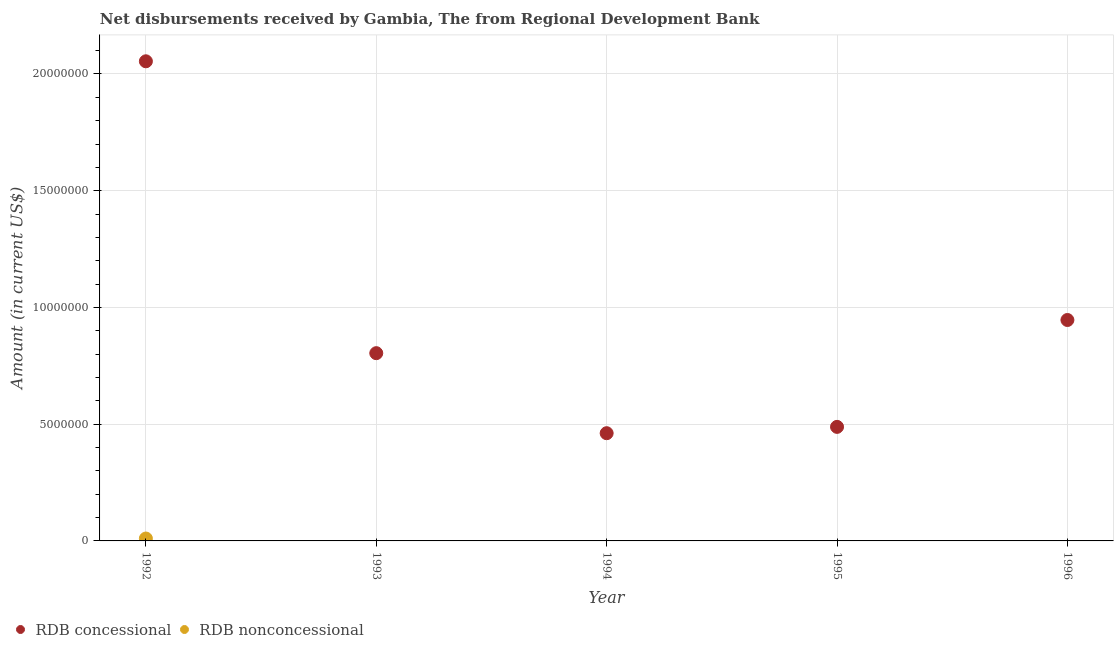How many different coloured dotlines are there?
Offer a very short reply. 2. Is the number of dotlines equal to the number of legend labels?
Your answer should be compact. No. Across all years, what is the maximum net concessional disbursements from rdb?
Offer a very short reply. 2.05e+07. Across all years, what is the minimum net non concessional disbursements from rdb?
Offer a very short reply. 0. What is the total net concessional disbursements from rdb in the graph?
Your response must be concise. 4.75e+07. What is the difference between the net concessional disbursements from rdb in 1993 and that in 1994?
Your answer should be very brief. 3.43e+06. What is the difference between the net concessional disbursements from rdb in 1993 and the net non concessional disbursements from rdb in 1996?
Your response must be concise. 8.04e+06. What is the average net concessional disbursements from rdb per year?
Your response must be concise. 9.51e+06. In how many years, is the net concessional disbursements from rdb greater than 1000000 US$?
Ensure brevity in your answer.  5. What is the ratio of the net concessional disbursements from rdb in 1992 to that in 1993?
Give a very brief answer. 2.55. Is the net concessional disbursements from rdb in 1992 less than that in 1994?
Give a very brief answer. No. What is the difference between the highest and the second highest net concessional disbursements from rdb?
Your answer should be very brief. 1.11e+07. What is the difference between the highest and the lowest net concessional disbursements from rdb?
Give a very brief answer. 1.59e+07. In how many years, is the net non concessional disbursements from rdb greater than the average net non concessional disbursements from rdb taken over all years?
Ensure brevity in your answer.  1. How many dotlines are there?
Ensure brevity in your answer.  2. How many years are there in the graph?
Give a very brief answer. 5. What is the difference between two consecutive major ticks on the Y-axis?
Keep it short and to the point. 5.00e+06. Are the values on the major ticks of Y-axis written in scientific E-notation?
Your answer should be compact. No. How many legend labels are there?
Your response must be concise. 2. What is the title of the graph?
Give a very brief answer. Net disbursements received by Gambia, The from Regional Development Bank. What is the label or title of the X-axis?
Provide a succinct answer. Year. What is the label or title of the Y-axis?
Keep it short and to the point. Amount (in current US$). What is the Amount (in current US$) of RDB concessional in 1992?
Your response must be concise. 2.05e+07. What is the Amount (in current US$) of RDB nonconcessional in 1992?
Provide a succinct answer. 1.03e+05. What is the Amount (in current US$) in RDB concessional in 1993?
Provide a succinct answer. 8.04e+06. What is the Amount (in current US$) of RDB nonconcessional in 1993?
Give a very brief answer. 0. What is the Amount (in current US$) in RDB concessional in 1994?
Your answer should be compact. 4.61e+06. What is the Amount (in current US$) of RDB concessional in 1995?
Your answer should be very brief. 4.88e+06. What is the Amount (in current US$) of RDB concessional in 1996?
Your answer should be very brief. 9.46e+06. Across all years, what is the maximum Amount (in current US$) in RDB concessional?
Provide a short and direct response. 2.05e+07. Across all years, what is the maximum Amount (in current US$) of RDB nonconcessional?
Offer a terse response. 1.03e+05. Across all years, what is the minimum Amount (in current US$) of RDB concessional?
Make the answer very short. 4.61e+06. What is the total Amount (in current US$) of RDB concessional in the graph?
Offer a terse response. 4.75e+07. What is the total Amount (in current US$) in RDB nonconcessional in the graph?
Offer a very short reply. 1.03e+05. What is the difference between the Amount (in current US$) of RDB concessional in 1992 and that in 1993?
Make the answer very short. 1.25e+07. What is the difference between the Amount (in current US$) in RDB concessional in 1992 and that in 1994?
Ensure brevity in your answer.  1.59e+07. What is the difference between the Amount (in current US$) of RDB concessional in 1992 and that in 1995?
Give a very brief answer. 1.57e+07. What is the difference between the Amount (in current US$) of RDB concessional in 1992 and that in 1996?
Provide a succinct answer. 1.11e+07. What is the difference between the Amount (in current US$) in RDB concessional in 1993 and that in 1994?
Your answer should be very brief. 3.43e+06. What is the difference between the Amount (in current US$) of RDB concessional in 1993 and that in 1995?
Provide a succinct answer. 3.16e+06. What is the difference between the Amount (in current US$) of RDB concessional in 1993 and that in 1996?
Your response must be concise. -1.42e+06. What is the difference between the Amount (in current US$) in RDB concessional in 1994 and that in 1995?
Keep it short and to the point. -2.71e+05. What is the difference between the Amount (in current US$) in RDB concessional in 1994 and that in 1996?
Make the answer very short. -4.85e+06. What is the difference between the Amount (in current US$) in RDB concessional in 1995 and that in 1996?
Your response must be concise. -4.58e+06. What is the average Amount (in current US$) of RDB concessional per year?
Your answer should be compact. 9.51e+06. What is the average Amount (in current US$) in RDB nonconcessional per year?
Offer a very short reply. 2.06e+04. In the year 1992, what is the difference between the Amount (in current US$) of RDB concessional and Amount (in current US$) of RDB nonconcessional?
Offer a very short reply. 2.04e+07. What is the ratio of the Amount (in current US$) of RDB concessional in 1992 to that in 1993?
Give a very brief answer. 2.55. What is the ratio of the Amount (in current US$) in RDB concessional in 1992 to that in 1994?
Offer a terse response. 4.45. What is the ratio of the Amount (in current US$) of RDB concessional in 1992 to that in 1995?
Your answer should be very brief. 4.21. What is the ratio of the Amount (in current US$) in RDB concessional in 1992 to that in 1996?
Offer a terse response. 2.17. What is the ratio of the Amount (in current US$) in RDB concessional in 1993 to that in 1994?
Your answer should be compact. 1.74. What is the ratio of the Amount (in current US$) of RDB concessional in 1993 to that in 1995?
Offer a very short reply. 1.65. What is the ratio of the Amount (in current US$) of RDB concessional in 1993 to that in 1996?
Your answer should be compact. 0.85. What is the ratio of the Amount (in current US$) in RDB concessional in 1994 to that in 1995?
Give a very brief answer. 0.94. What is the ratio of the Amount (in current US$) of RDB concessional in 1994 to that in 1996?
Make the answer very short. 0.49. What is the ratio of the Amount (in current US$) of RDB concessional in 1995 to that in 1996?
Provide a succinct answer. 0.52. What is the difference between the highest and the second highest Amount (in current US$) in RDB concessional?
Your response must be concise. 1.11e+07. What is the difference between the highest and the lowest Amount (in current US$) of RDB concessional?
Ensure brevity in your answer.  1.59e+07. What is the difference between the highest and the lowest Amount (in current US$) of RDB nonconcessional?
Provide a succinct answer. 1.03e+05. 